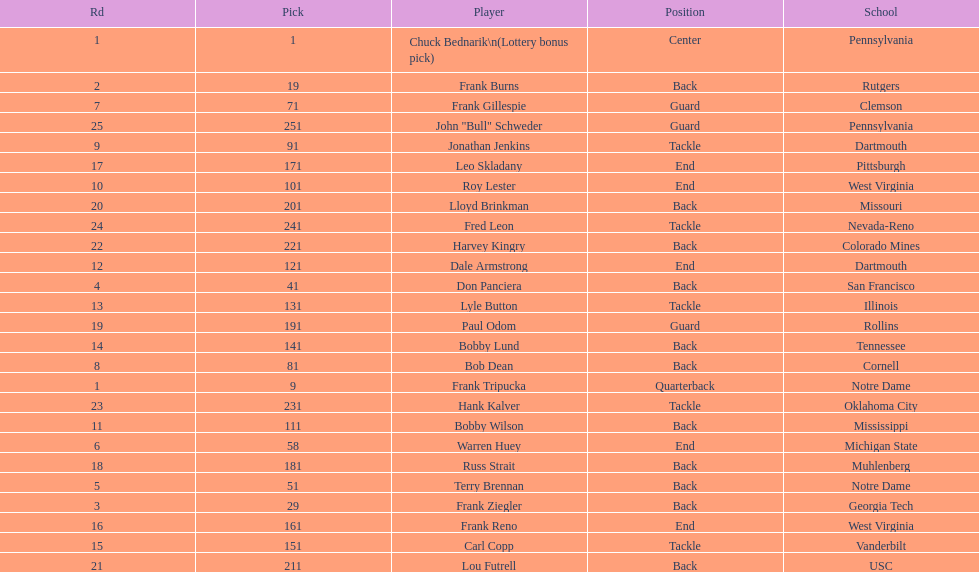Most prevalent school Pennsylvania. 